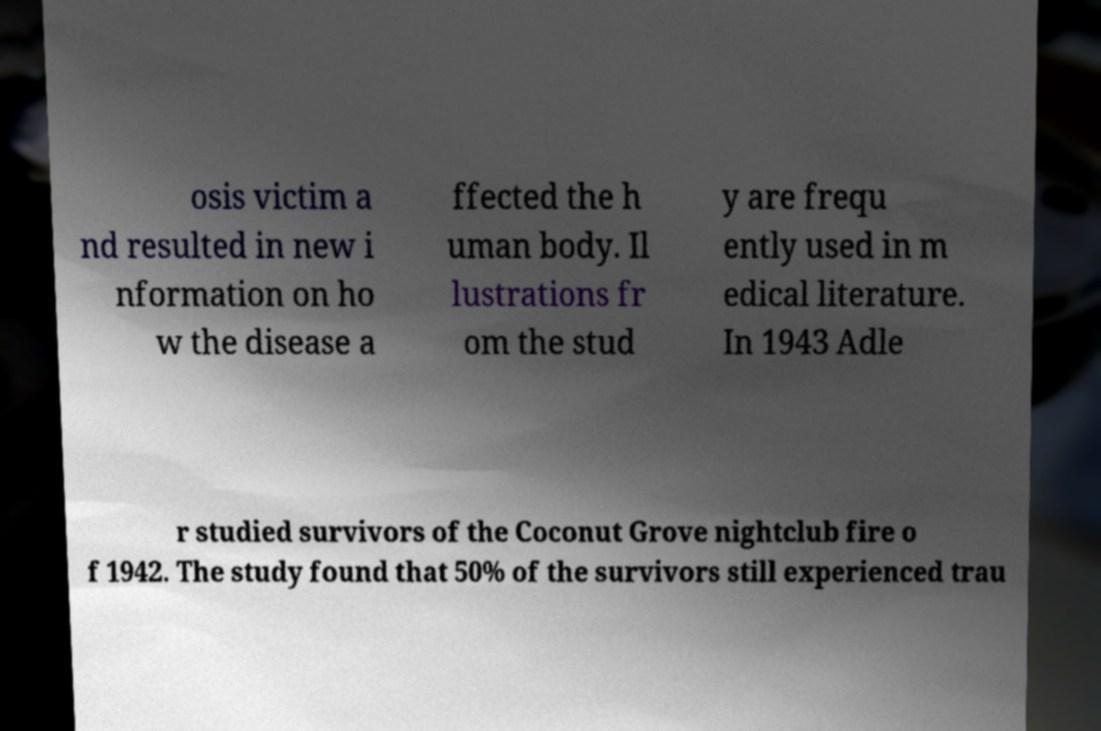What messages or text are displayed in this image? I need them in a readable, typed format. osis victim a nd resulted in new i nformation on ho w the disease a ffected the h uman body. Il lustrations fr om the stud y are frequ ently used in m edical literature. In 1943 Adle r studied survivors of the Coconut Grove nightclub fire o f 1942. The study found that 50% of the survivors still experienced trau 